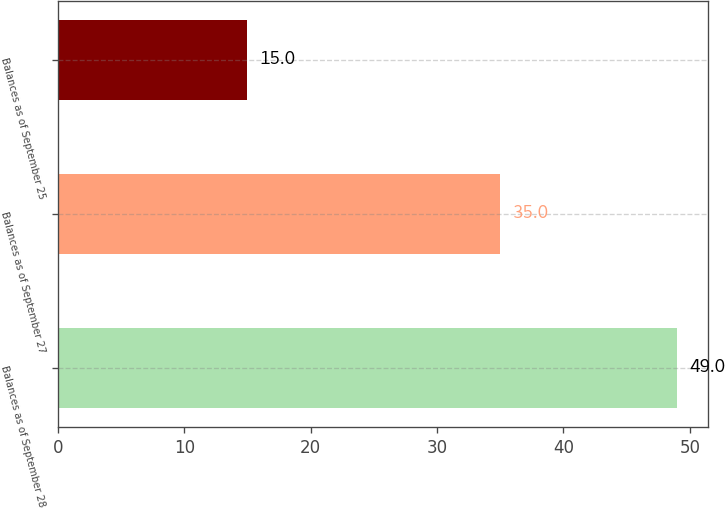Convert chart to OTSL. <chart><loc_0><loc_0><loc_500><loc_500><bar_chart><fcel>Balances as of September 28<fcel>Balances as of September 27<fcel>Balances as of September 25<nl><fcel>49<fcel>35<fcel>15<nl></chart> 